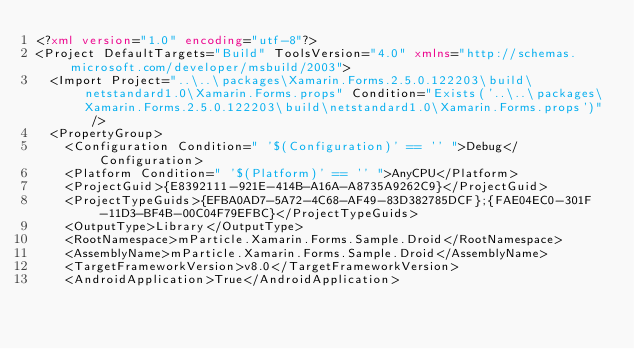Convert code to text. <code><loc_0><loc_0><loc_500><loc_500><_XML_><?xml version="1.0" encoding="utf-8"?>
<Project DefaultTargets="Build" ToolsVersion="4.0" xmlns="http://schemas.microsoft.com/developer/msbuild/2003">
  <Import Project="..\..\packages\Xamarin.Forms.2.5.0.122203\build\netstandard1.0\Xamarin.Forms.props" Condition="Exists('..\..\packages\Xamarin.Forms.2.5.0.122203\build\netstandard1.0\Xamarin.Forms.props')" />
  <PropertyGroup>
    <Configuration Condition=" '$(Configuration)' == '' ">Debug</Configuration>
    <Platform Condition=" '$(Platform)' == '' ">AnyCPU</Platform>
    <ProjectGuid>{E8392111-921E-414B-A16A-A8735A9262C9}</ProjectGuid>
    <ProjectTypeGuids>{EFBA0AD7-5A72-4C68-AF49-83D382785DCF};{FAE04EC0-301F-11D3-BF4B-00C04F79EFBC}</ProjectTypeGuids>
    <OutputType>Library</OutputType>
    <RootNamespace>mParticle.Xamarin.Forms.Sample.Droid</RootNamespace>
    <AssemblyName>mParticle.Xamarin.Forms.Sample.Droid</AssemblyName>
    <TargetFrameworkVersion>v8.0</TargetFrameworkVersion>
    <AndroidApplication>True</AndroidApplication></code> 